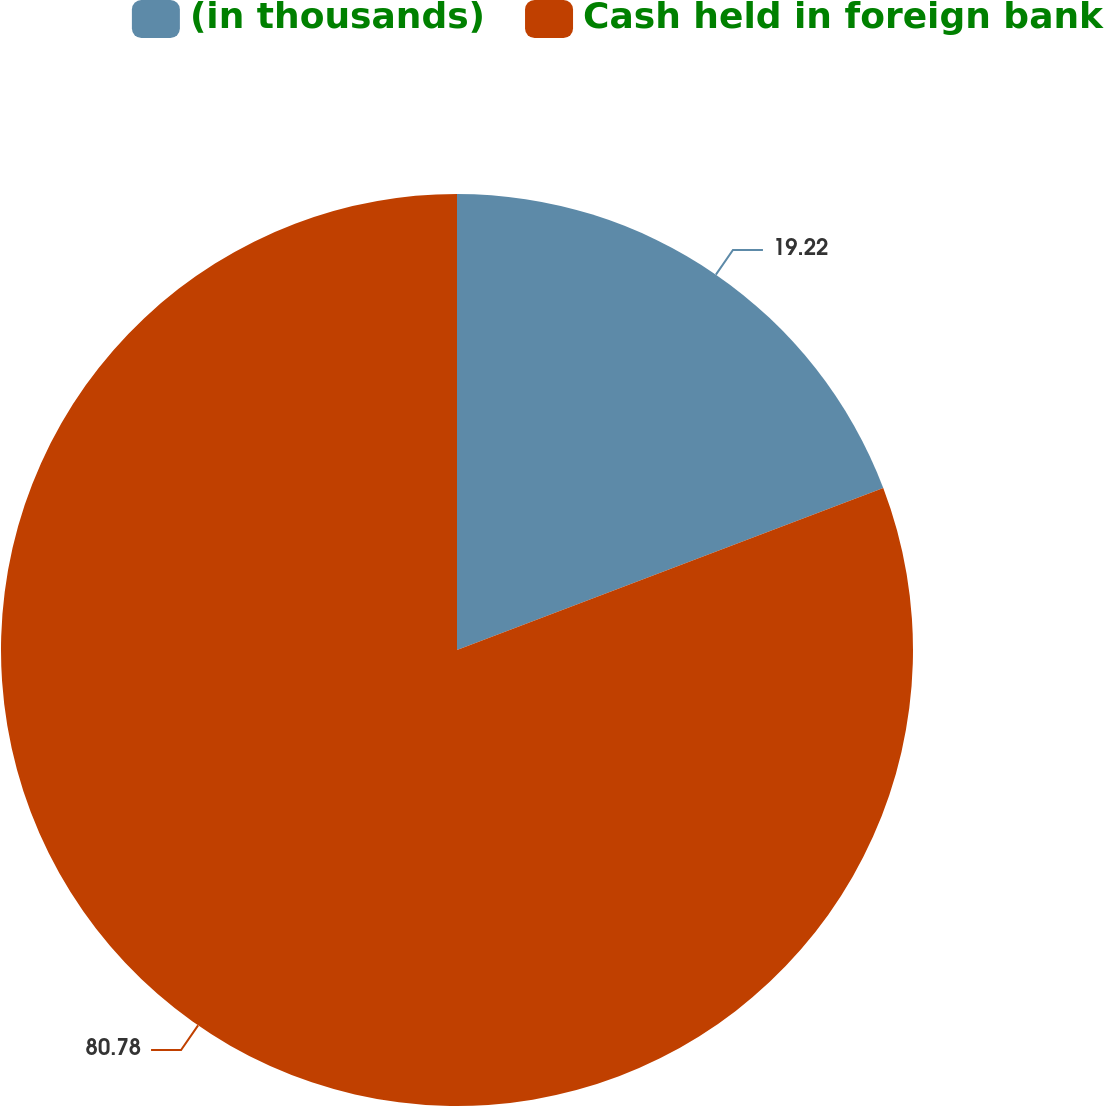Convert chart to OTSL. <chart><loc_0><loc_0><loc_500><loc_500><pie_chart><fcel>(in thousands)<fcel>Cash held in foreign bank<nl><fcel>19.22%<fcel>80.78%<nl></chart> 